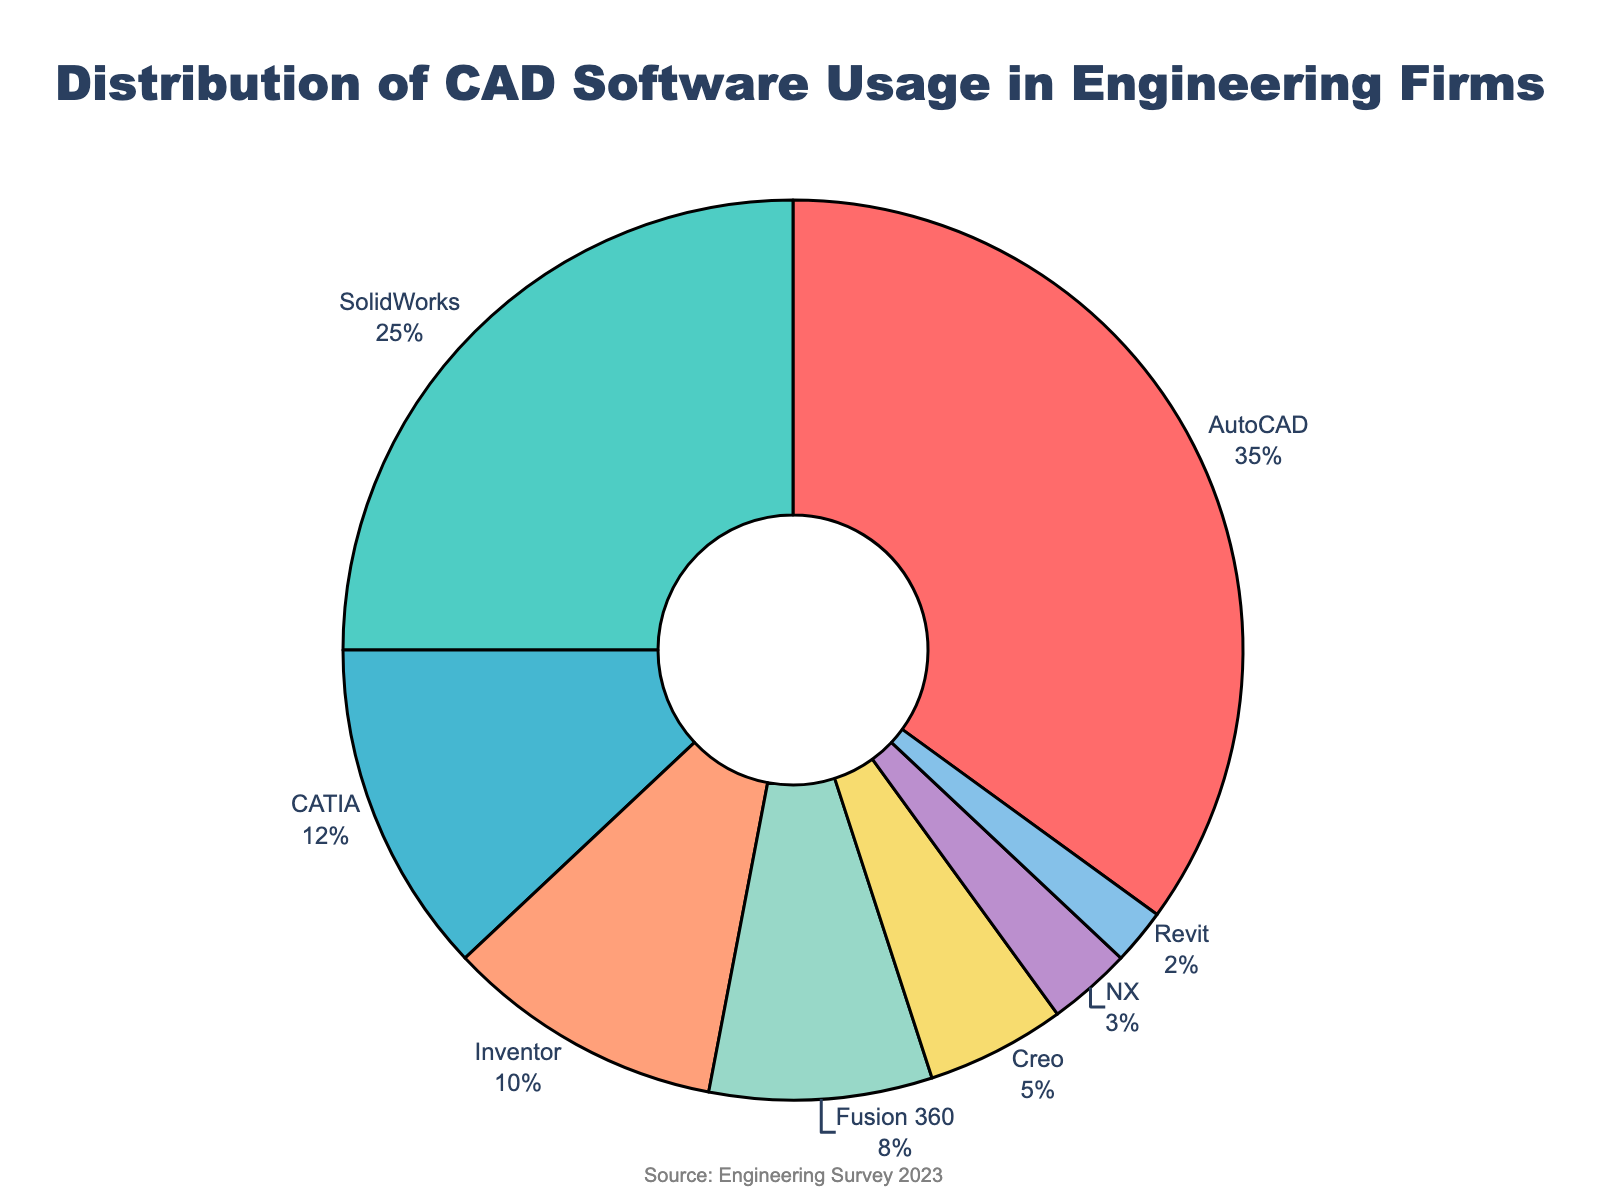What percentage of engineering firms use AutoCAD? By looking at the pie chart, we can see that AutoCAD represents a segment labeled with its percentage.
Answer: 35% Which CAD software has the second-highest usage and what is its percentage? From the pie chart, the largest segment is AutoCAD at 35%. The next largest segment is SolidWorks with a label indicating its percentage.
Answer: SolidWorks, 25% How much larger is the percentage of firms using SolidWorks compared to CATIA? The chart shows SolidWorks usage at 25% and CATIA at 12%. Subtract CATIA's percentage from SolidWorks' percentage (25% - 12%).
Answer: 13% What is the combined percentage of firms using Inventor and Fusion 360? From the chart, Inventor has 10%, and Fusion 360 has 8%. Adding these together (10% + 8%).
Answer: 18% List the CAD software used by fewer than 10% of the firms. The chart's segments reveal percentages for each software. Scan for those under 10%, including CATIA (12%), followed by Inventor (10%), Fusion 360 (8%), Creo (5%), NX (3%) and Revit (2%).
Answer: Fusion 360, Creo, NX, Revit Which CAD software usage is closest in percentage to that of Revit? According to the chart, Revit has 2%. NX is the closest one with 3%.
Answer: NX Is the percentage of firms using SolidWorks greater than those using Inventor and Fusion 360 combined? The chart shows SolidWorks at 25%. Inventor is at 10% and Fusion 360 at 8%, together making 18%. SolidWorks has a higher percentage than the combined.
Answer: Yes What is the percentage difference between the highest and the lowest usage software? The chart shows AutoCAD with the highest usage at 35% and Revit with the lowest at 2%. The difference is (35% - 2%).
Answer: 33% What is the total percentage of firms using either AutoCAD or Creo? The chart shows AutoCAD at 35% and Creo at 5%. Adding these together (35% + 5%).
Answer: 40% If you group the software into two categories, one with usage above 15% and the other with usage 15% or less, which software falls into each category? The chart indicates that AutoCAD (35%) and SolidWorks (25%) are above 15%. CATIA (12%), Inventor (10%), Fusion 360 (8%), Creo (5%), NX (3%), and Revit (2%) are 15% or less.
Answer: Above 15%: AutoCAD and SolidWorks; 15% or less: CATIA, Inventor, Fusion 360, Creo, NX, and Revit 